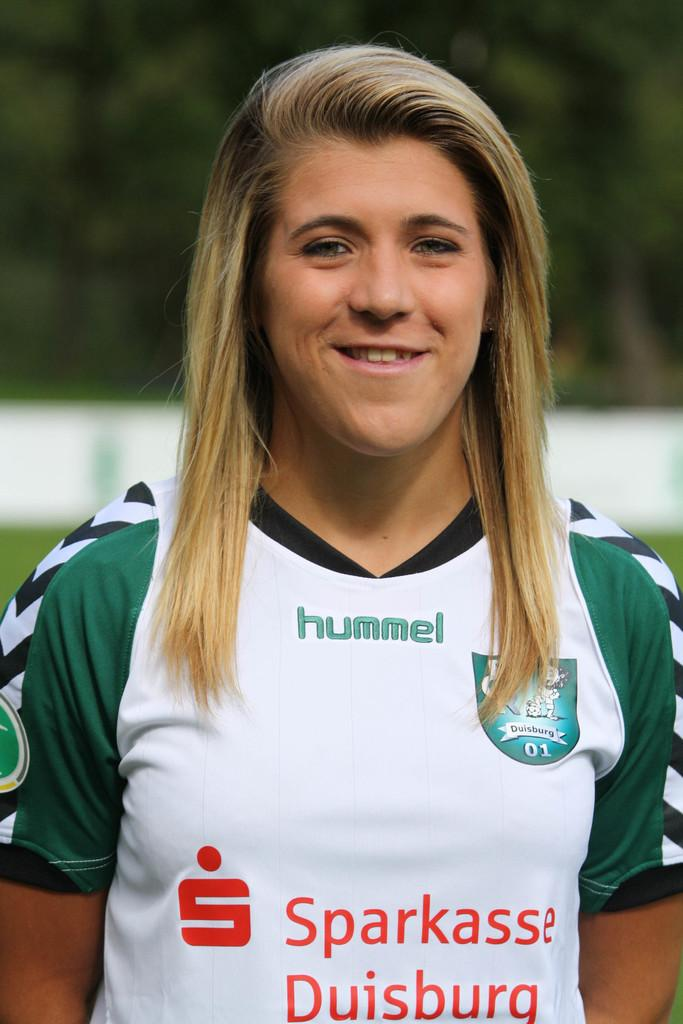<image>
Give a short and clear explanation of the subsequent image. Young women in uniform, team jersey says hummel on the t-shirt 